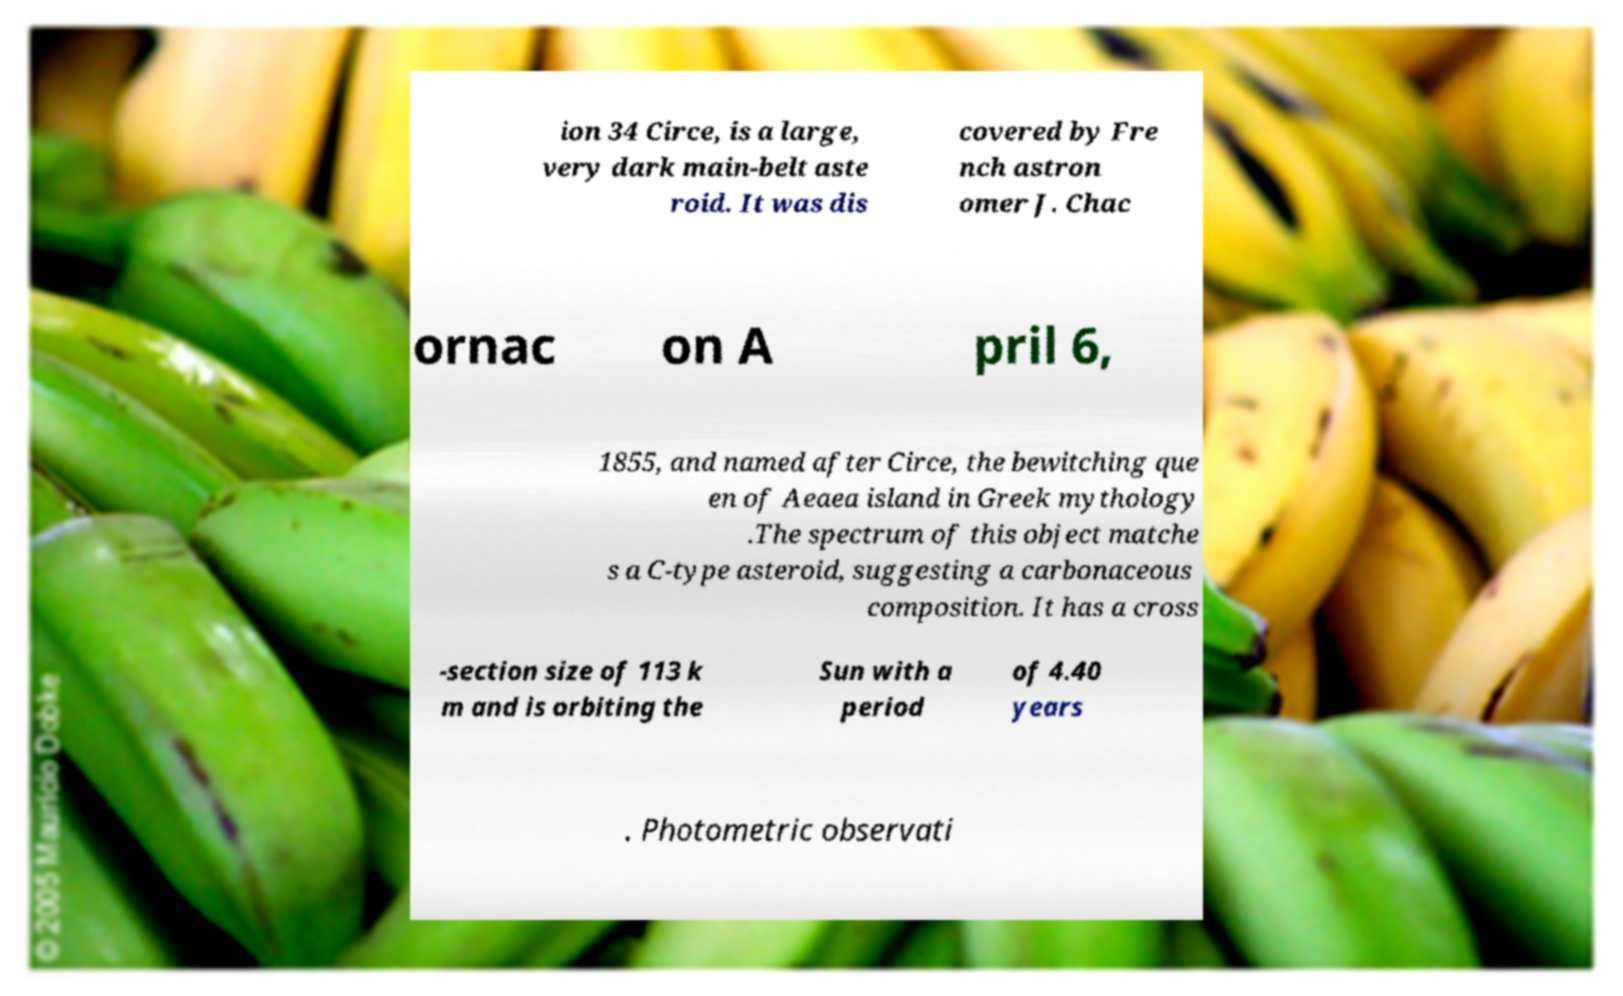Could you assist in decoding the text presented in this image and type it out clearly? ion 34 Circe, is a large, very dark main-belt aste roid. It was dis covered by Fre nch astron omer J. Chac ornac on A pril 6, 1855, and named after Circe, the bewitching que en of Aeaea island in Greek mythology .The spectrum of this object matche s a C-type asteroid, suggesting a carbonaceous composition. It has a cross -section size of 113 k m and is orbiting the Sun with a period of 4.40 years . Photometric observati 